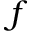<formula> <loc_0><loc_0><loc_500><loc_500>f</formula> 